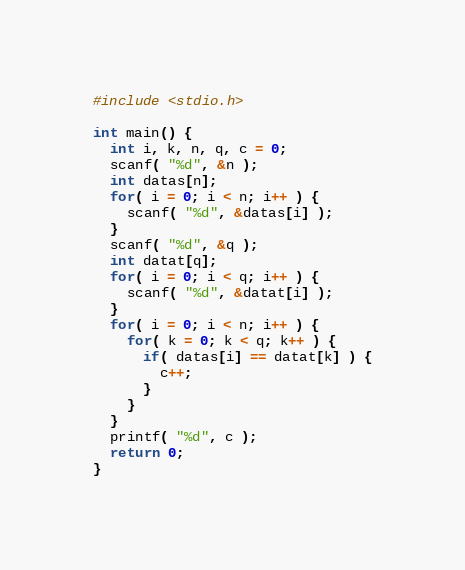Convert code to text. <code><loc_0><loc_0><loc_500><loc_500><_C_>#include <stdio.h>

int main() {
  int i, k, n, q, c = 0;
  scanf( "%d", &n );
  int datas[n];
  for( i = 0; i < n; i++ ) {
    scanf( "%d", &datas[i] );
  }
  scanf( "%d", &q );
  int datat[q];
  for( i = 0; i < q; i++ ) {
    scanf( "%d", &datat[i] );
  }
  for( i = 0; i < n; i++ ) {
    for( k = 0; k < q; k++ ) {
      if( datas[i] == datat[k] ) {
        c++;
      }
    }
  }
  printf( "%d", c );
  return 0;
}</code> 